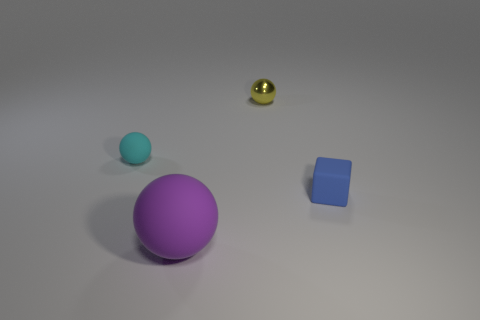Is there any other thing that is the same shape as the tiny blue matte object?
Make the answer very short. No. What number of objects are either tiny things on the left side of the yellow thing or small red spheres?
Your response must be concise. 1. Does the large matte thing have the same shape as the small yellow metal thing?
Your answer should be very brief. Yes. What number of other things are the same size as the purple sphere?
Make the answer very short. 0. The small shiny sphere has what color?
Offer a very short reply. Yellow. What number of large objects are either brown metallic objects or purple balls?
Keep it short and to the point. 1. Do the object that is behind the cyan ball and the ball that is left of the purple matte sphere have the same size?
Ensure brevity in your answer.  Yes. What is the size of the purple matte object that is the same shape as the yellow metallic thing?
Your answer should be compact. Large. Are there more objects that are on the left side of the small yellow object than tiny blue matte cubes that are in front of the blue cube?
Your answer should be compact. Yes. What material is the thing that is to the right of the purple matte sphere and left of the small blue matte block?
Offer a very short reply. Metal. 